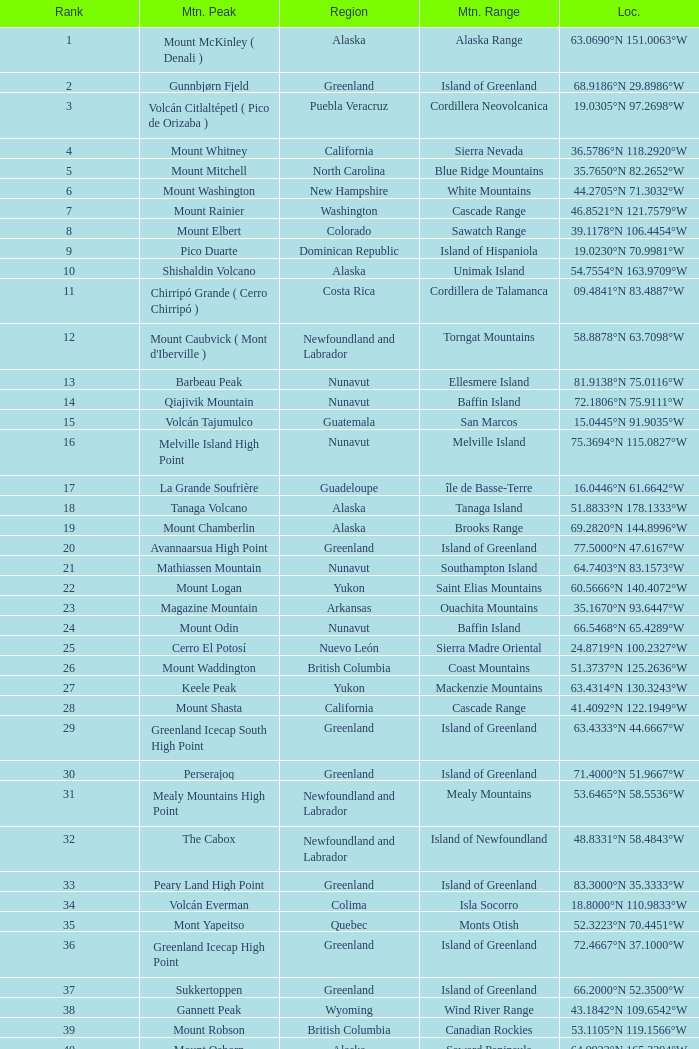What is the mountain range that includes a haitian region located at coordinates 18.3601°n 71.9764°w? Island of Hispaniola. 